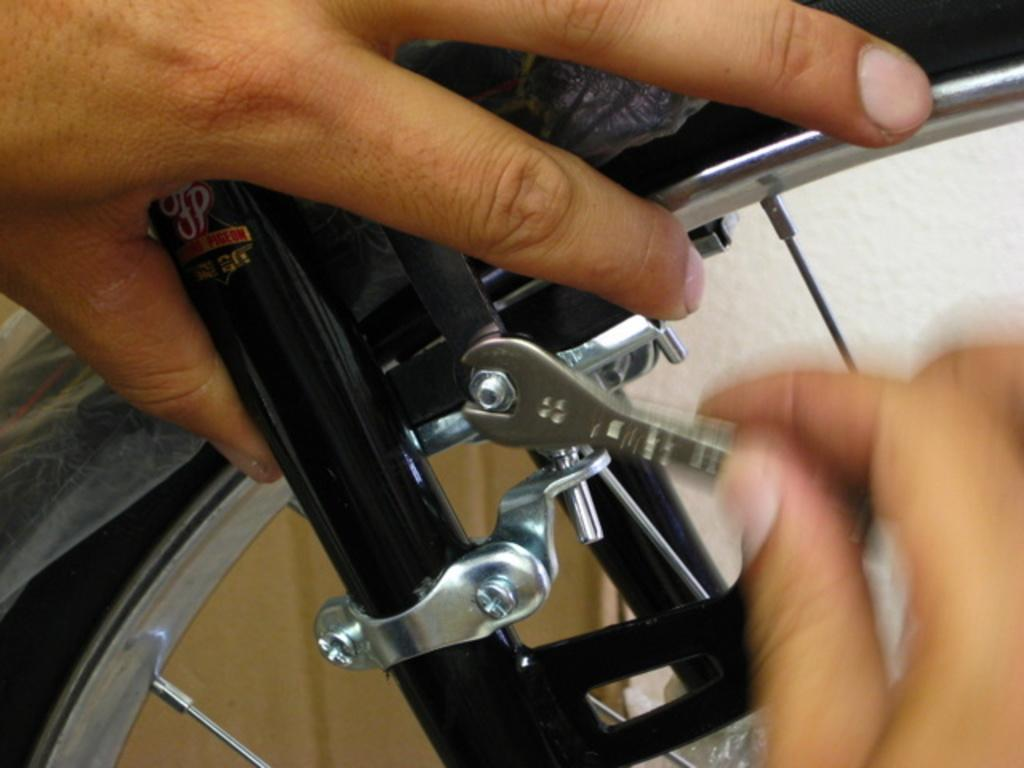What is the main object in the center of the image? There is a cycle wheel in the center of the image. What tool is present in the image? There is a wrench in the image. Who is holding the wrench in the image? There is a hand holding the wrench in the image. Are there any other hands visible in the image? Yes, there is another hand visible in the image. What type of comb is being used by the maid in the image? There is no maid or comb present in the image. Who is the expert in the image? The image does not depict an expert or any specific skill being demonstrated. 